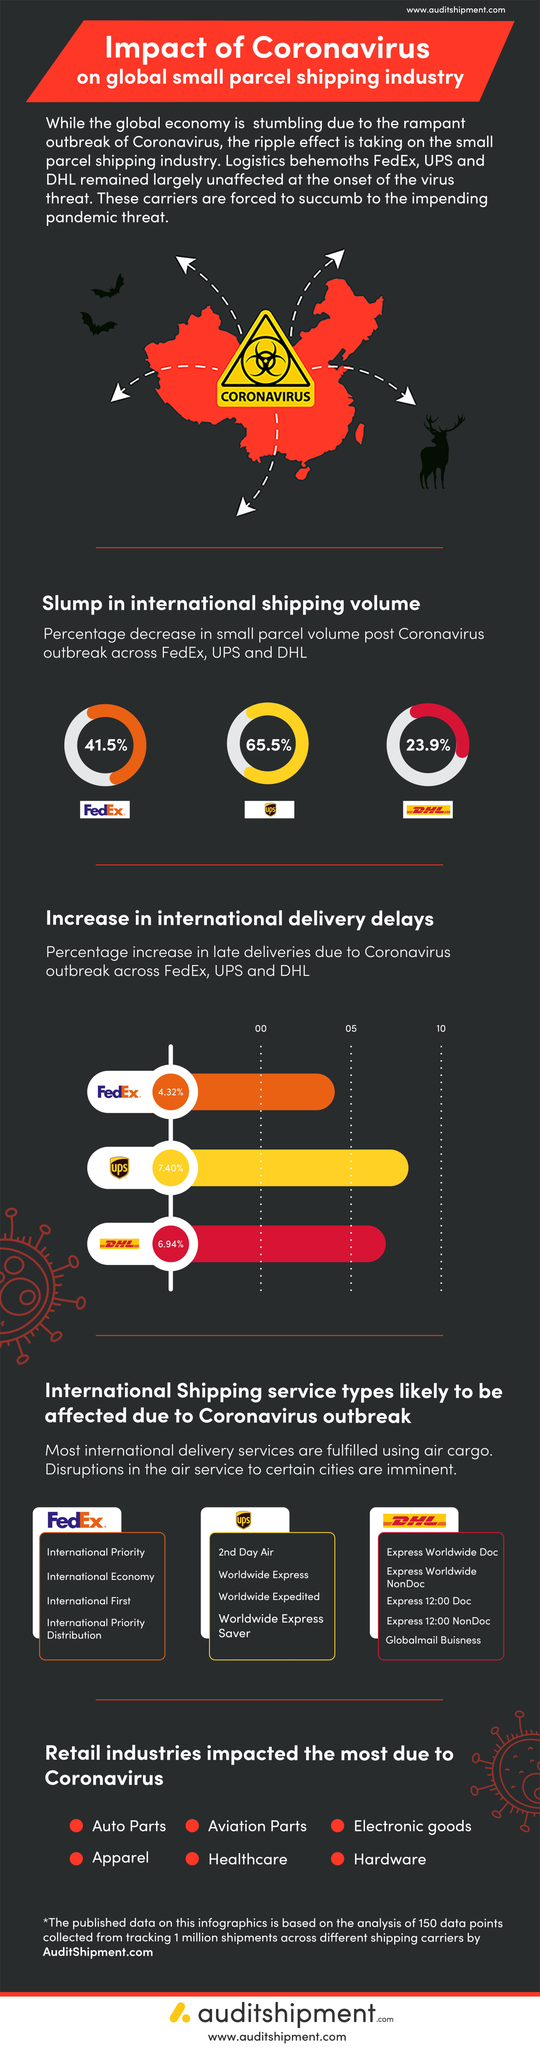Specify some key components in this picture. The international shipping volume of UPS decreased by 65.5% after the COVID-19 pandemic. During the post-Covid pandemic, FedEx reported a 41.5% decrease in small parcel volume compared to the same period in the previous year. During the post-Covid time, DHL saw a 23.9% decrease in small parcel volume. UPS has experienced the highest percentage increase in late deliveries compared to other logistics companies due to the COVID-19 outbreak. 